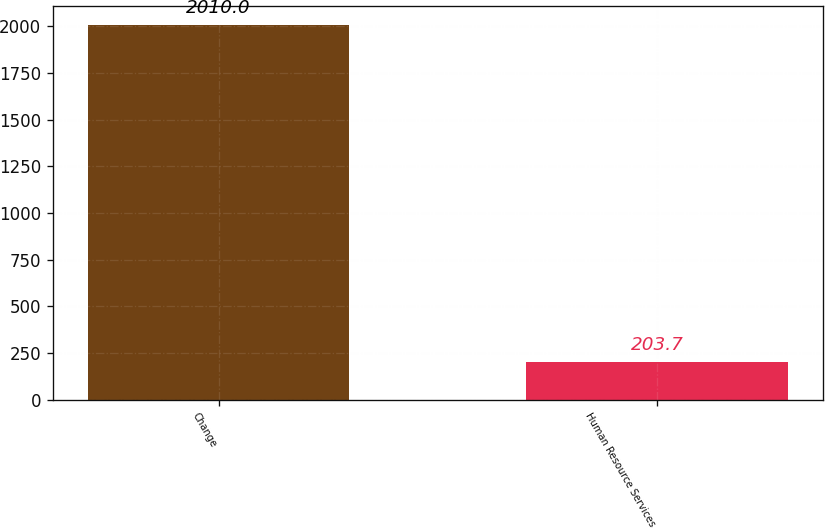<chart> <loc_0><loc_0><loc_500><loc_500><bar_chart><fcel>Change<fcel>Human Resource Services<nl><fcel>2010<fcel>203.7<nl></chart> 